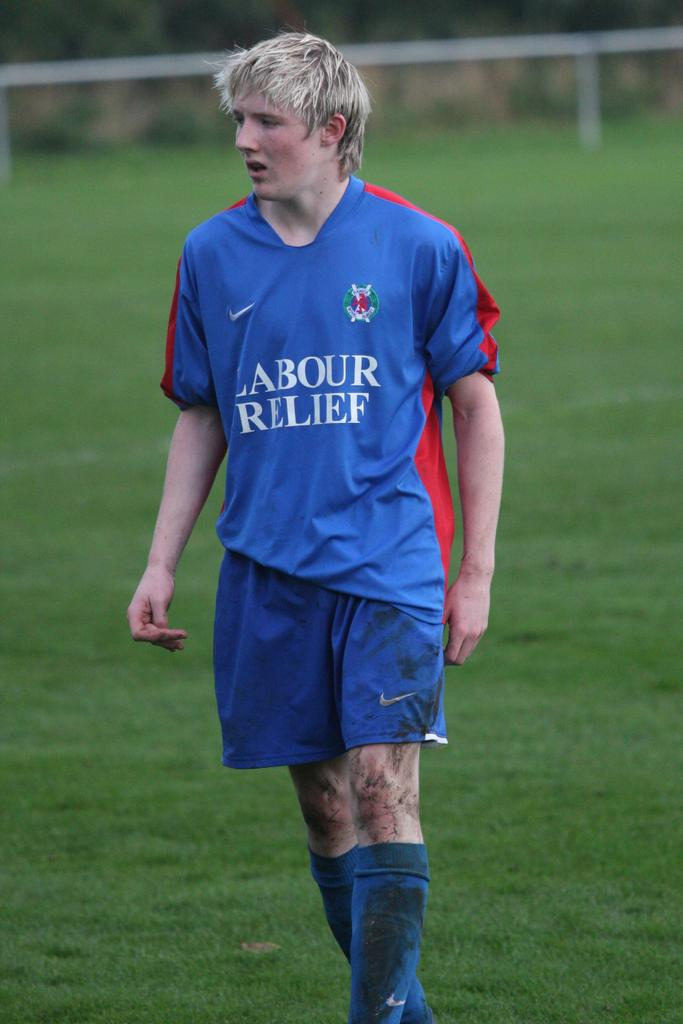<image>
Describe the image concisely. boy wearing blue nike shorts and jersey with labour relief on it 